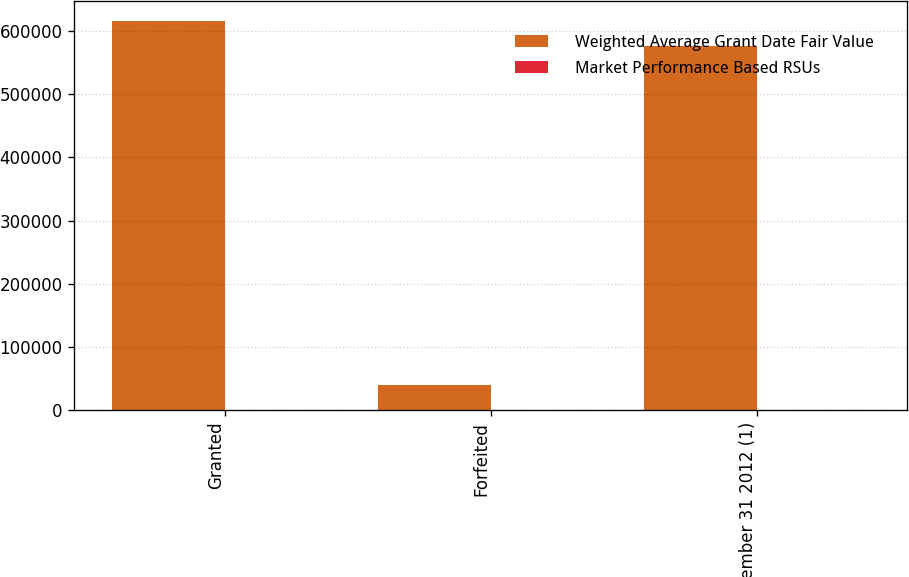Convert chart to OTSL. <chart><loc_0><loc_0><loc_500><loc_500><stacked_bar_chart><ecel><fcel>Granted<fcel>Forfeited<fcel>December 31 2012 (1)<nl><fcel>Weighted Average Grant Date Fair Value<fcel>616117<fcel>40585<fcel>575532<nl><fcel>Market Performance Based RSUs<fcel>115.03<fcel>115.03<fcel>115.03<nl></chart> 